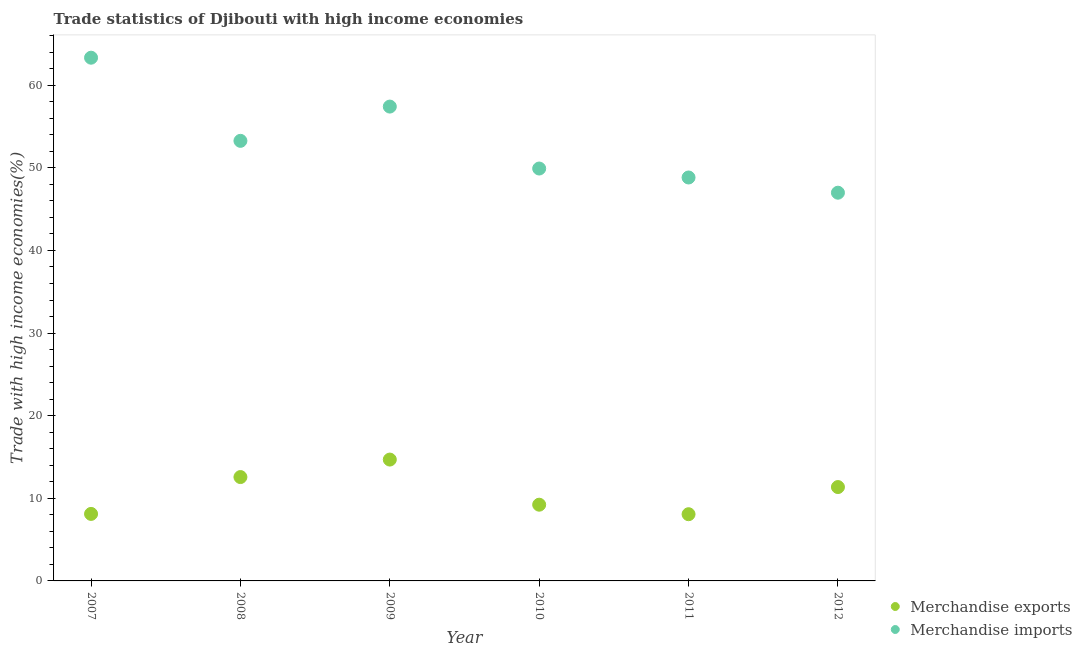How many different coloured dotlines are there?
Make the answer very short. 2. What is the merchandise exports in 2008?
Provide a short and direct response. 12.57. Across all years, what is the maximum merchandise exports?
Provide a short and direct response. 14.69. Across all years, what is the minimum merchandise exports?
Your answer should be compact. 8.07. In which year was the merchandise exports minimum?
Offer a terse response. 2011. What is the total merchandise imports in the graph?
Ensure brevity in your answer.  319.73. What is the difference between the merchandise exports in 2008 and that in 2011?
Give a very brief answer. 4.5. What is the difference between the merchandise exports in 2011 and the merchandise imports in 2008?
Your answer should be compact. -45.19. What is the average merchandise exports per year?
Ensure brevity in your answer.  10.67. In the year 2012, what is the difference between the merchandise exports and merchandise imports?
Offer a very short reply. -35.63. In how many years, is the merchandise imports greater than 44 %?
Your answer should be very brief. 6. What is the ratio of the merchandise imports in 2009 to that in 2011?
Make the answer very short. 1.18. What is the difference between the highest and the second highest merchandise imports?
Offer a very short reply. 5.92. What is the difference between the highest and the lowest merchandise exports?
Your answer should be very brief. 6.61. In how many years, is the merchandise exports greater than the average merchandise exports taken over all years?
Offer a terse response. 3. Is the sum of the merchandise exports in 2008 and 2009 greater than the maximum merchandise imports across all years?
Ensure brevity in your answer.  No. Does the merchandise imports monotonically increase over the years?
Give a very brief answer. No. Is the merchandise imports strictly greater than the merchandise exports over the years?
Your answer should be compact. Yes. Is the merchandise exports strictly less than the merchandise imports over the years?
Offer a terse response. Yes. What is the difference between two consecutive major ticks on the Y-axis?
Your response must be concise. 10. Are the values on the major ticks of Y-axis written in scientific E-notation?
Ensure brevity in your answer.  No. Where does the legend appear in the graph?
Your answer should be compact. Bottom right. What is the title of the graph?
Ensure brevity in your answer.  Trade statistics of Djibouti with high income economies. Does "Nitrous oxide" appear as one of the legend labels in the graph?
Make the answer very short. No. What is the label or title of the X-axis?
Make the answer very short. Year. What is the label or title of the Y-axis?
Provide a short and direct response. Trade with high income economies(%). What is the Trade with high income economies(%) of Merchandise exports in 2007?
Offer a very short reply. 8.11. What is the Trade with high income economies(%) of Merchandise imports in 2007?
Offer a very short reply. 63.33. What is the Trade with high income economies(%) of Merchandise exports in 2008?
Provide a short and direct response. 12.57. What is the Trade with high income economies(%) in Merchandise imports in 2008?
Ensure brevity in your answer.  53.26. What is the Trade with high income economies(%) in Merchandise exports in 2009?
Offer a terse response. 14.69. What is the Trade with high income economies(%) of Merchandise imports in 2009?
Ensure brevity in your answer.  57.41. What is the Trade with high income economies(%) in Merchandise exports in 2010?
Your response must be concise. 9.23. What is the Trade with high income economies(%) in Merchandise imports in 2010?
Offer a terse response. 49.91. What is the Trade with high income economies(%) of Merchandise exports in 2011?
Give a very brief answer. 8.07. What is the Trade with high income economies(%) in Merchandise imports in 2011?
Make the answer very short. 48.83. What is the Trade with high income economies(%) in Merchandise exports in 2012?
Your response must be concise. 11.36. What is the Trade with high income economies(%) of Merchandise imports in 2012?
Your answer should be very brief. 46.99. Across all years, what is the maximum Trade with high income economies(%) of Merchandise exports?
Ensure brevity in your answer.  14.69. Across all years, what is the maximum Trade with high income economies(%) in Merchandise imports?
Keep it short and to the point. 63.33. Across all years, what is the minimum Trade with high income economies(%) in Merchandise exports?
Keep it short and to the point. 8.07. Across all years, what is the minimum Trade with high income economies(%) in Merchandise imports?
Offer a terse response. 46.99. What is the total Trade with high income economies(%) of Merchandise exports in the graph?
Keep it short and to the point. 64.03. What is the total Trade with high income economies(%) in Merchandise imports in the graph?
Your response must be concise. 319.73. What is the difference between the Trade with high income economies(%) in Merchandise exports in 2007 and that in 2008?
Keep it short and to the point. -4.46. What is the difference between the Trade with high income economies(%) of Merchandise imports in 2007 and that in 2008?
Give a very brief answer. 10.06. What is the difference between the Trade with high income economies(%) in Merchandise exports in 2007 and that in 2009?
Offer a very short reply. -6.58. What is the difference between the Trade with high income economies(%) of Merchandise imports in 2007 and that in 2009?
Give a very brief answer. 5.92. What is the difference between the Trade with high income economies(%) in Merchandise exports in 2007 and that in 2010?
Keep it short and to the point. -1.12. What is the difference between the Trade with high income economies(%) in Merchandise imports in 2007 and that in 2010?
Your answer should be compact. 13.41. What is the difference between the Trade with high income economies(%) of Merchandise exports in 2007 and that in 2011?
Provide a succinct answer. 0.04. What is the difference between the Trade with high income economies(%) in Merchandise imports in 2007 and that in 2011?
Keep it short and to the point. 14.5. What is the difference between the Trade with high income economies(%) in Merchandise exports in 2007 and that in 2012?
Offer a terse response. -3.25. What is the difference between the Trade with high income economies(%) of Merchandise imports in 2007 and that in 2012?
Your answer should be very brief. 16.34. What is the difference between the Trade with high income economies(%) of Merchandise exports in 2008 and that in 2009?
Keep it short and to the point. -2.12. What is the difference between the Trade with high income economies(%) in Merchandise imports in 2008 and that in 2009?
Offer a terse response. -4.15. What is the difference between the Trade with high income economies(%) of Merchandise exports in 2008 and that in 2010?
Keep it short and to the point. 3.34. What is the difference between the Trade with high income economies(%) in Merchandise imports in 2008 and that in 2010?
Your answer should be very brief. 3.35. What is the difference between the Trade with high income economies(%) in Merchandise exports in 2008 and that in 2011?
Make the answer very short. 4.5. What is the difference between the Trade with high income economies(%) of Merchandise imports in 2008 and that in 2011?
Offer a terse response. 4.43. What is the difference between the Trade with high income economies(%) in Merchandise exports in 2008 and that in 2012?
Give a very brief answer. 1.21. What is the difference between the Trade with high income economies(%) in Merchandise imports in 2008 and that in 2012?
Make the answer very short. 6.28. What is the difference between the Trade with high income economies(%) of Merchandise exports in 2009 and that in 2010?
Your answer should be compact. 5.46. What is the difference between the Trade with high income economies(%) of Merchandise imports in 2009 and that in 2010?
Your response must be concise. 7.5. What is the difference between the Trade with high income economies(%) in Merchandise exports in 2009 and that in 2011?
Make the answer very short. 6.61. What is the difference between the Trade with high income economies(%) in Merchandise imports in 2009 and that in 2011?
Ensure brevity in your answer.  8.58. What is the difference between the Trade with high income economies(%) of Merchandise exports in 2009 and that in 2012?
Offer a very short reply. 3.33. What is the difference between the Trade with high income economies(%) in Merchandise imports in 2009 and that in 2012?
Make the answer very short. 10.42. What is the difference between the Trade with high income economies(%) in Merchandise exports in 2010 and that in 2011?
Offer a terse response. 1.15. What is the difference between the Trade with high income economies(%) of Merchandise imports in 2010 and that in 2011?
Offer a terse response. 1.08. What is the difference between the Trade with high income economies(%) of Merchandise exports in 2010 and that in 2012?
Offer a very short reply. -2.13. What is the difference between the Trade with high income economies(%) of Merchandise imports in 2010 and that in 2012?
Give a very brief answer. 2.93. What is the difference between the Trade with high income economies(%) in Merchandise exports in 2011 and that in 2012?
Offer a very short reply. -3.29. What is the difference between the Trade with high income economies(%) in Merchandise imports in 2011 and that in 2012?
Provide a short and direct response. 1.84. What is the difference between the Trade with high income economies(%) in Merchandise exports in 2007 and the Trade with high income economies(%) in Merchandise imports in 2008?
Offer a very short reply. -45.15. What is the difference between the Trade with high income economies(%) of Merchandise exports in 2007 and the Trade with high income economies(%) of Merchandise imports in 2009?
Provide a succinct answer. -49.3. What is the difference between the Trade with high income economies(%) in Merchandise exports in 2007 and the Trade with high income economies(%) in Merchandise imports in 2010?
Provide a short and direct response. -41.8. What is the difference between the Trade with high income economies(%) in Merchandise exports in 2007 and the Trade with high income economies(%) in Merchandise imports in 2011?
Offer a very short reply. -40.72. What is the difference between the Trade with high income economies(%) of Merchandise exports in 2007 and the Trade with high income economies(%) of Merchandise imports in 2012?
Ensure brevity in your answer.  -38.88. What is the difference between the Trade with high income economies(%) in Merchandise exports in 2008 and the Trade with high income economies(%) in Merchandise imports in 2009?
Offer a terse response. -44.84. What is the difference between the Trade with high income economies(%) of Merchandise exports in 2008 and the Trade with high income economies(%) of Merchandise imports in 2010?
Ensure brevity in your answer.  -37.34. What is the difference between the Trade with high income economies(%) in Merchandise exports in 2008 and the Trade with high income economies(%) in Merchandise imports in 2011?
Offer a terse response. -36.26. What is the difference between the Trade with high income economies(%) in Merchandise exports in 2008 and the Trade with high income economies(%) in Merchandise imports in 2012?
Provide a succinct answer. -34.42. What is the difference between the Trade with high income economies(%) of Merchandise exports in 2009 and the Trade with high income economies(%) of Merchandise imports in 2010?
Provide a succinct answer. -35.23. What is the difference between the Trade with high income economies(%) of Merchandise exports in 2009 and the Trade with high income economies(%) of Merchandise imports in 2011?
Ensure brevity in your answer.  -34.14. What is the difference between the Trade with high income economies(%) of Merchandise exports in 2009 and the Trade with high income economies(%) of Merchandise imports in 2012?
Give a very brief answer. -32.3. What is the difference between the Trade with high income economies(%) in Merchandise exports in 2010 and the Trade with high income economies(%) in Merchandise imports in 2011?
Provide a succinct answer. -39.6. What is the difference between the Trade with high income economies(%) in Merchandise exports in 2010 and the Trade with high income economies(%) in Merchandise imports in 2012?
Provide a short and direct response. -37.76. What is the difference between the Trade with high income economies(%) of Merchandise exports in 2011 and the Trade with high income economies(%) of Merchandise imports in 2012?
Your answer should be compact. -38.91. What is the average Trade with high income economies(%) of Merchandise exports per year?
Make the answer very short. 10.67. What is the average Trade with high income economies(%) in Merchandise imports per year?
Your response must be concise. 53.29. In the year 2007, what is the difference between the Trade with high income economies(%) of Merchandise exports and Trade with high income economies(%) of Merchandise imports?
Your answer should be compact. -55.22. In the year 2008, what is the difference between the Trade with high income economies(%) of Merchandise exports and Trade with high income economies(%) of Merchandise imports?
Your response must be concise. -40.69. In the year 2009, what is the difference between the Trade with high income economies(%) of Merchandise exports and Trade with high income economies(%) of Merchandise imports?
Provide a succinct answer. -42.72. In the year 2010, what is the difference between the Trade with high income economies(%) of Merchandise exports and Trade with high income economies(%) of Merchandise imports?
Provide a short and direct response. -40.69. In the year 2011, what is the difference between the Trade with high income economies(%) of Merchandise exports and Trade with high income economies(%) of Merchandise imports?
Make the answer very short. -40.75. In the year 2012, what is the difference between the Trade with high income economies(%) of Merchandise exports and Trade with high income economies(%) of Merchandise imports?
Keep it short and to the point. -35.63. What is the ratio of the Trade with high income economies(%) in Merchandise exports in 2007 to that in 2008?
Provide a succinct answer. 0.65. What is the ratio of the Trade with high income economies(%) in Merchandise imports in 2007 to that in 2008?
Offer a very short reply. 1.19. What is the ratio of the Trade with high income economies(%) of Merchandise exports in 2007 to that in 2009?
Give a very brief answer. 0.55. What is the ratio of the Trade with high income economies(%) of Merchandise imports in 2007 to that in 2009?
Keep it short and to the point. 1.1. What is the ratio of the Trade with high income economies(%) in Merchandise exports in 2007 to that in 2010?
Your response must be concise. 0.88. What is the ratio of the Trade with high income economies(%) in Merchandise imports in 2007 to that in 2010?
Provide a succinct answer. 1.27. What is the ratio of the Trade with high income economies(%) of Merchandise imports in 2007 to that in 2011?
Provide a succinct answer. 1.3. What is the ratio of the Trade with high income economies(%) of Merchandise exports in 2007 to that in 2012?
Ensure brevity in your answer.  0.71. What is the ratio of the Trade with high income economies(%) of Merchandise imports in 2007 to that in 2012?
Your answer should be compact. 1.35. What is the ratio of the Trade with high income economies(%) in Merchandise exports in 2008 to that in 2009?
Provide a succinct answer. 0.86. What is the ratio of the Trade with high income economies(%) of Merchandise imports in 2008 to that in 2009?
Give a very brief answer. 0.93. What is the ratio of the Trade with high income economies(%) in Merchandise exports in 2008 to that in 2010?
Provide a succinct answer. 1.36. What is the ratio of the Trade with high income economies(%) of Merchandise imports in 2008 to that in 2010?
Provide a short and direct response. 1.07. What is the ratio of the Trade with high income economies(%) in Merchandise exports in 2008 to that in 2011?
Provide a short and direct response. 1.56. What is the ratio of the Trade with high income economies(%) in Merchandise imports in 2008 to that in 2011?
Your response must be concise. 1.09. What is the ratio of the Trade with high income economies(%) of Merchandise exports in 2008 to that in 2012?
Offer a terse response. 1.11. What is the ratio of the Trade with high income economies(%) of Merchandise imports in 2008 to that in 2012?
Offer a very short reply. 1.13. What is the ratio of the Trade with high income economies(%) in Merchandise exports in 2009 to that in 2010?
Provide a short and direct response. 1.59. What is the ratio of the Trade with high income economies(%) in Merchandise imports in 2009 to that in 2010?
Ensure brevity in your answer.  1.15. What is the ratio of the Trade with high income economies(%) of Merchandise exports in 2009 to that in 2011?
Offer a very short reply. 1.82. What is the ratio of the Trade with high income economies(%) of Merchandise imports in 2009 to that in 2011?
Provide a succinct answer. 1.18. What is the ratio of the Trade with high income economies(%) of Merchandise exports in 2009 to that in 2012?
Make the answer very short. 1.29. What is the ratio of the Trade with high income economies(%) of Merchandise imports in 2009 to that in 2012?
Your answer should be compact. 1.22. What is the ratio of the Trade with high income economies(%) of Merchandise exports in 2010 to that in 2011?
Your answer should be very brief. 1.14. What is the ratio of the Trade with high income economies(%) of Merchandise imports in 2010 to that in 2011?
Make the answer very short. 1.02. What is the ratio of the Trade with high income economies(%) in Merchandise exports in 2010 to that in 2012?
Your answer should be very brief. 0.81. What is the ratio of the Trade with high income economies(%) in Merchandise imports in 2010 to that in 2012?
Ensure brevity in your answer.  1.06. What is the ratio of the Trade with high income economies(%) of Merchandise exports in 2011 to that in 2012?
Make the answer very short. 0.71. What is the ratio of the Trade with high income economies(%) of Merchandise imports in 2011 to that in 2012?
Your response must be concise. 1.04. What is the difference between the highest and the second highest Trade with high income economies(%) of Merchandise exports?
Your answer should be compact. 2.12. What is the difference between the highest and the second highest Trade with high income economies(%) in Merchandise imports?
Keep it short and to the point. 5.92. What is the difference between the highest and the lowest Trade with high income economies(%) of Merchandise exports?
Your response must be concise. 6.61. What is the difference between the highest and the lowest Trade with high income economies(%) in Merchandise imports?
Your answer should be very brief. 16.34. 